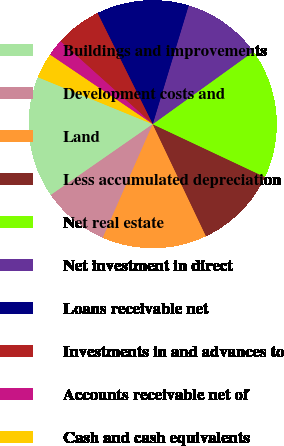Convert chart to OTSL. <chart><loc_0><loc_0><loc_500><loc_500><pie_chart><fcel>Buildings and improvements<fcel>Development costs and<fcel>Land<fcel>Less accumulated depreciation<fcel>Net real estate<fcel>Net investment in direct<fcel>Loans receivable net<fcel>Investments in and advances to<fcel>Accounts receivable net of<fcel>Cash and cash equivalents<nl><fcel>15.85%<fcel>8.74%<fcel>13.66%<fcel>10.93%<fcel>16.94%<fcel>10.38%<fcel>12.02%<fcel>6.01%<fcel>2.19%<fcel>3.28%<nl></chart> 